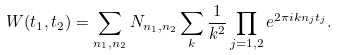Convert formula to latex. <formula><loc_0><loc_0><loc_500><loc_500>W ( t _ { 1 } , t _ { 2 } ) = \sum _ { n _ { 1 } , n _ { 2 } } N _ { n _ { 1 } , n _ { 2 } } \sum _ { k } \frac { 1 } { k ^ { 2 } } \prod _ { j = 1 , 2 } e ^ { 2 \pi i k n _ { j } t _ { j } } .</formula> 